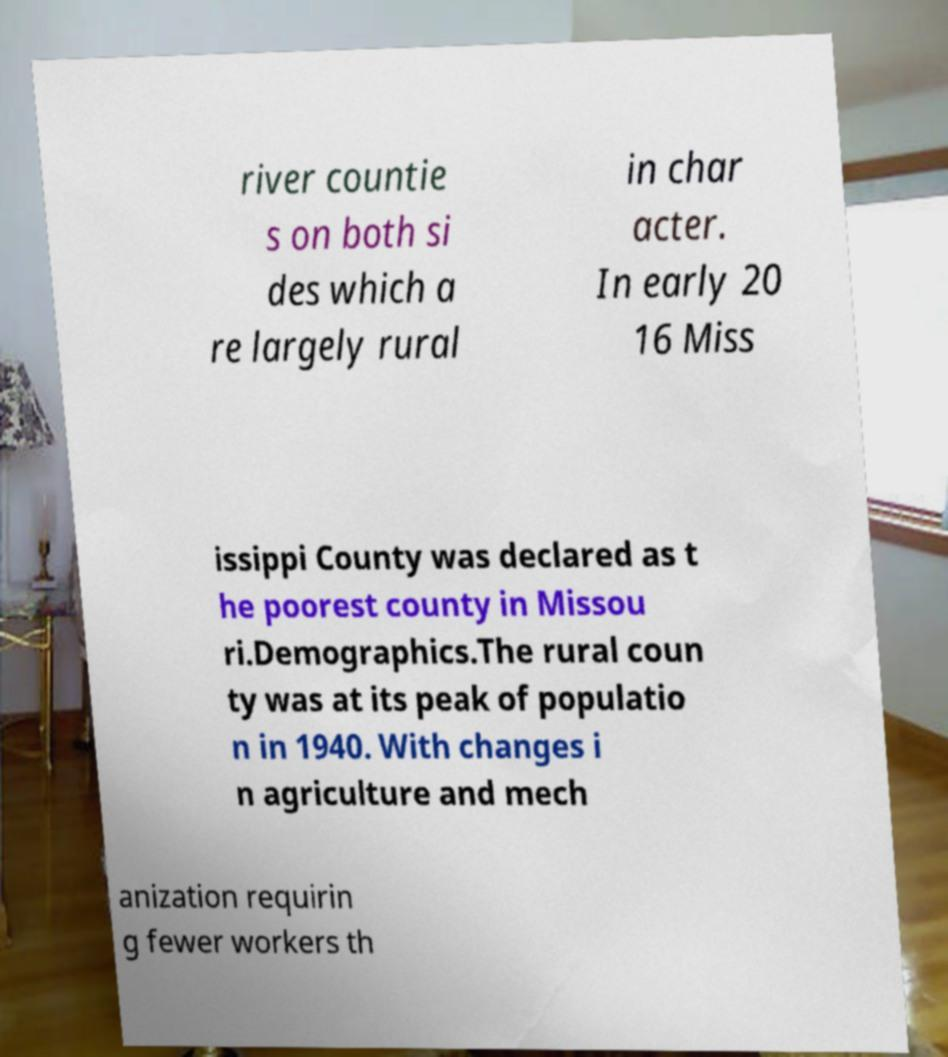Could you assist in decoding the text presented in this image and type it out clearly? river countie s on both si des which a re largely rural in char acter. In early 20 16 Miss issippi County was declared as t he poorest county in Missou ri.Demographics.The rural coun ty was at its peak of populatio n in 1940. With changes i n agriculture and mech anization requirin g fewer workers th 